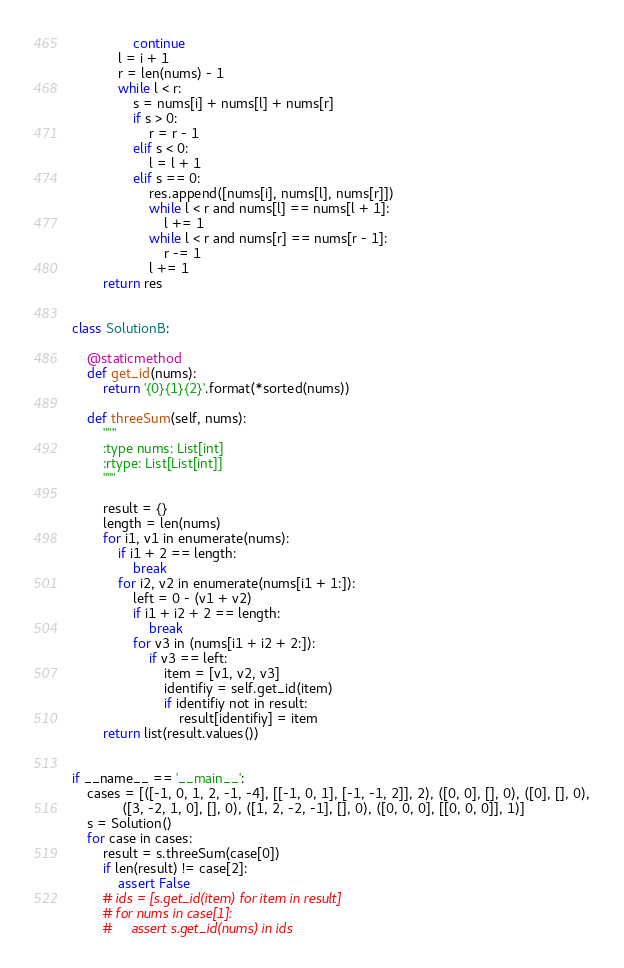<code> <loc_0><loc_0><loc_500><loc_500><_Python_>                continue
            l = i + 1
            r = len(nums) - 1
            while l < r:
                s = nums[i] + nums[l] + nums[r]
                if s > 0:
                    r = r - 1
                elif s < 0:
                    l = l + 1
                elif s == 0:
                    res.append([nums[i], nums[l], nums[r]])
                    while l < r and nums[l] == nums[l + 1]:
                        l += 1
                    while l < r and nums[r] == nums[r - 1]:
                        r -= 1
                    l += 1
        return res


class SolutionB:

    @staticmethod
    def get_id(nums):
        return '{0}{1}{2}'.format(*sorted(nums))

    def threeSum(self, nums):
        """
        :type nums: List[int]
        :rtype: List[List[int]]
        """

        result = {}
        length = len(nums)
        for i1, v1 in enumerate(nums):
            if i1 + 2 == length:
                break
            for i2, v2 in enumerate(nums[i1 + 1:]):
                left = 0 - (v1 + v2)
                if i1 + i2 + 2 == length:
                    break
                for v3 in (nums[i1 + i2 + 2:]):
                    if v3 == left:
                        item = [v1, v2, v3]
                        identifiy = self.get_id(item)
                        if identifiy not in result:
                            result[identifiy] = item
        return list(result.values())


if __name__ == '__main__':
    cases = [([-1, 0, 1, 2, -1, -4], [[-1, 0, 1], [-1, -1, 2]], 2), ([0, 0], [], 0), ([0], [], 0),
             ([3, -2, 1, 0], [], 0), ([1, 2, -2, -1], [], 0), ([0, 0, 0], [[0, 0, 0]], 1)]
    s = Solution()
    for case in cases:
        result = s.threeSum(case[0])
        if len(result) != case[2]:
            assert False
        # ids = [s.get_id(item) for item in result]
        # for nums in case[1]:
        #     assert s.get_id(nums) in ids
</code> 